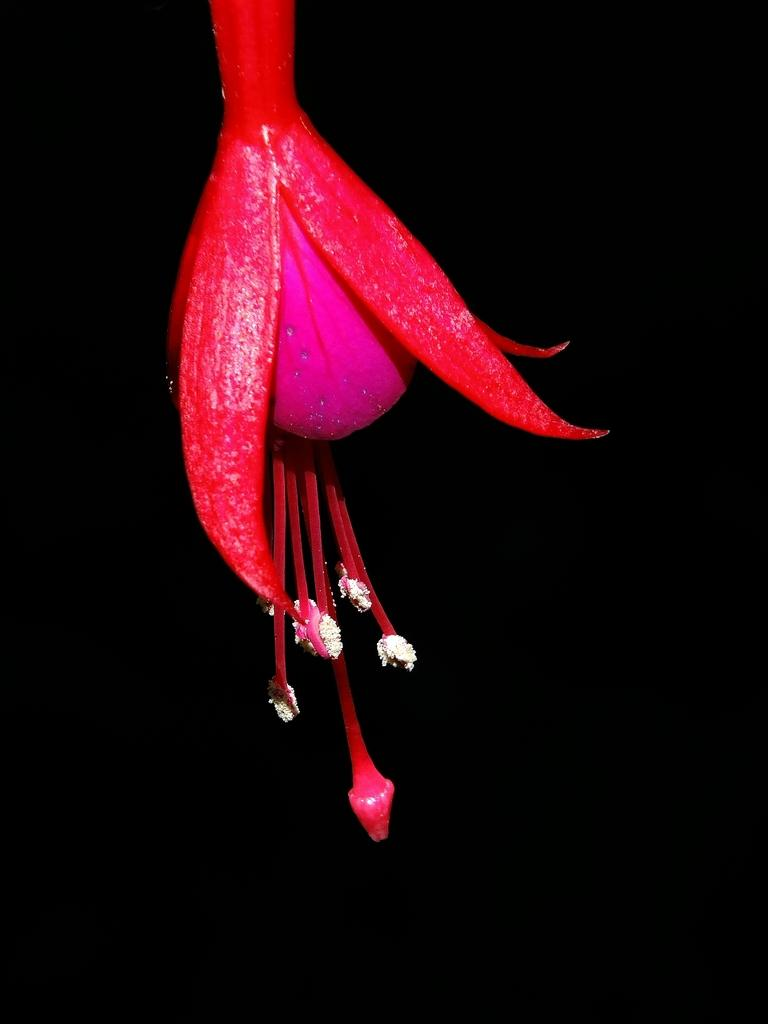What is the main subject of the image? There is a flower in the image. What can be observed about the background of the image? The background of the image is dark. Can you tell me how the argument between the two characters in the image is resolved? There are no characters or arguments present in the image; it features a flower and a dark background. 